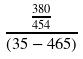<formula> <loc_0><loc_0><loc_500><loc_500>\frac { \frac { 3 8 0 } { 4 5 4 } } { ( 3 5 - 4 6 5 ) }</formula> 